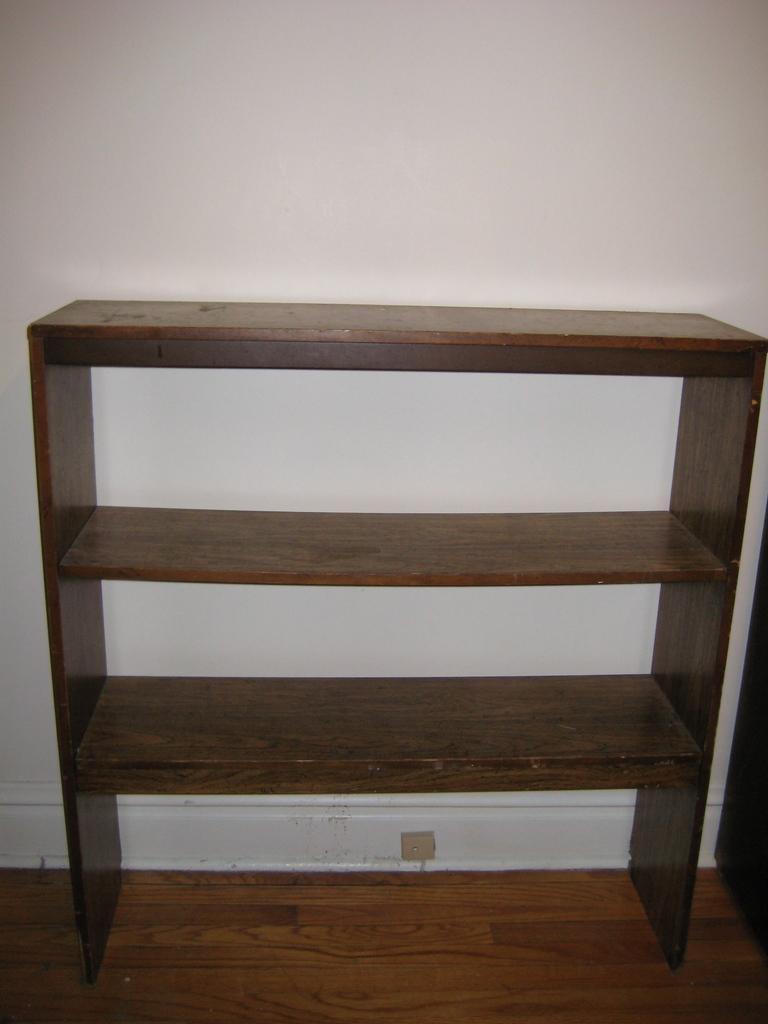How would you summarize this image in a sentence or two? In this image there is a shelf on a wooden floor, in the background there is a wall. 